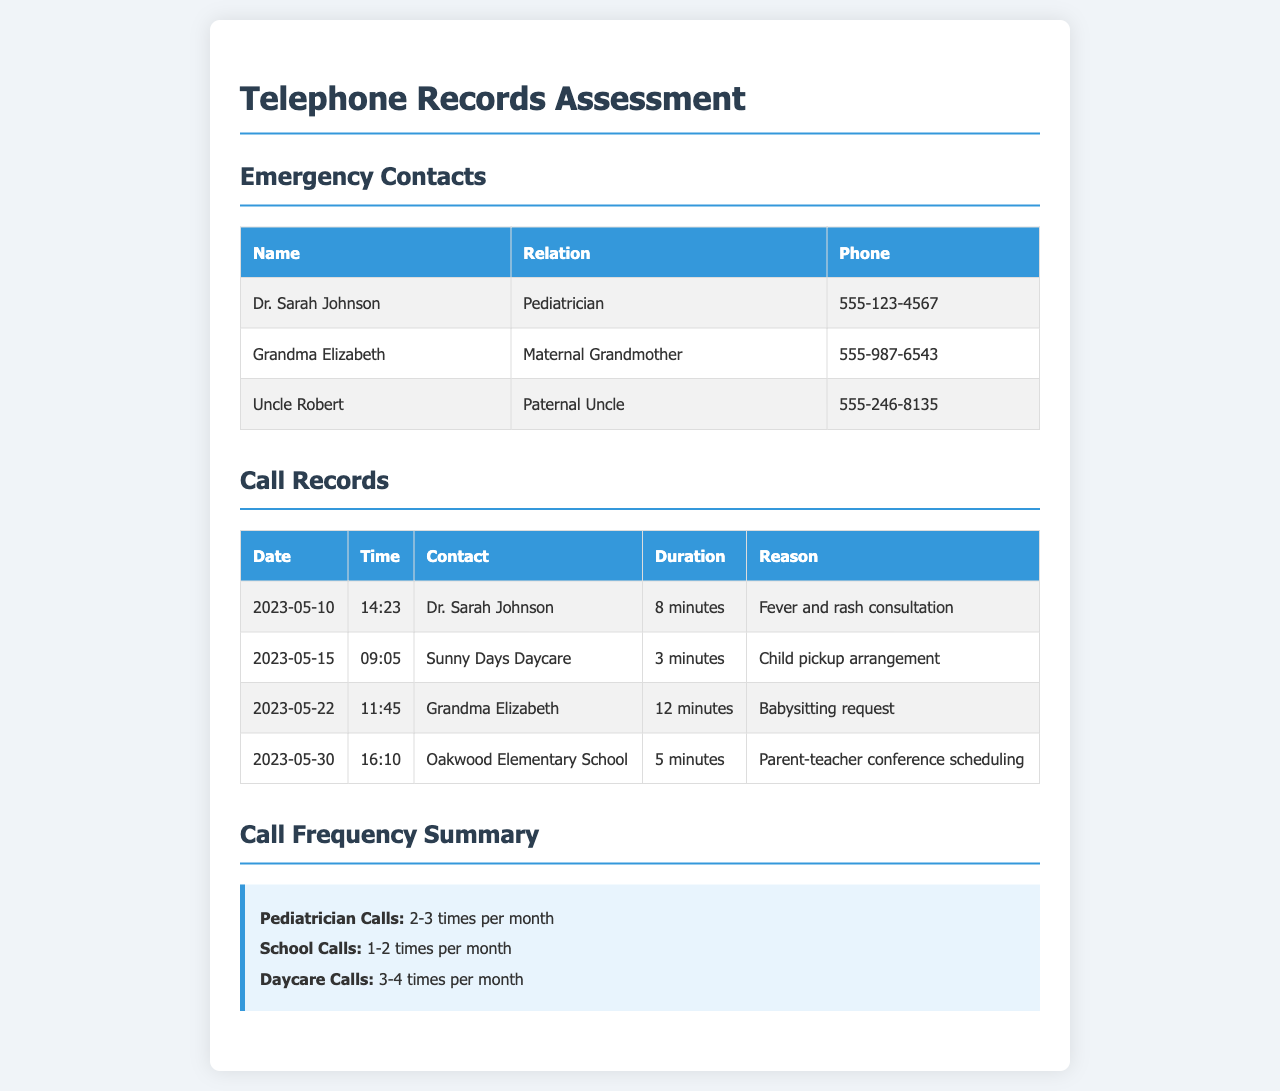What is the name of the pediatrician? The document lists the pediatrician as "Dr. Sarah Johnson".
Answer: Dr. Sarah Johnson How many times per month does the family call the pediatrician? The frequency summary indicates pediatrician calls occur 2-3 times per month.
Answer: 2-3 times What is the duration of the call made on May 10, 2023? The call duration for that date is mentioned as "8 minutes".
Answer: 8 minutes Which facility did the family call regarding a child pickup? The document states the call was made to "Sunny Days Daycare".
Answer: Sunny Days Daycare How many calls were made to daycare facilities in a month? The frequency summary specifies daycare calls as happening 3-4 times per month.
Answer: 3-4 times What was the reason for the call to Oakwood Elementary School? The reason is recorded as "Parent-teacher conference scheduling".
Answer: Parent-teacher conference scheduling Who was the call made to on May 22, 2023? The call was made to "Grandma Elizabeth".
Answer: Grandma Elizabeth How many calls were made to schools in a month? According to the frequency summary, school calls are 1-2 times per month.
Answer: 1-2 times 